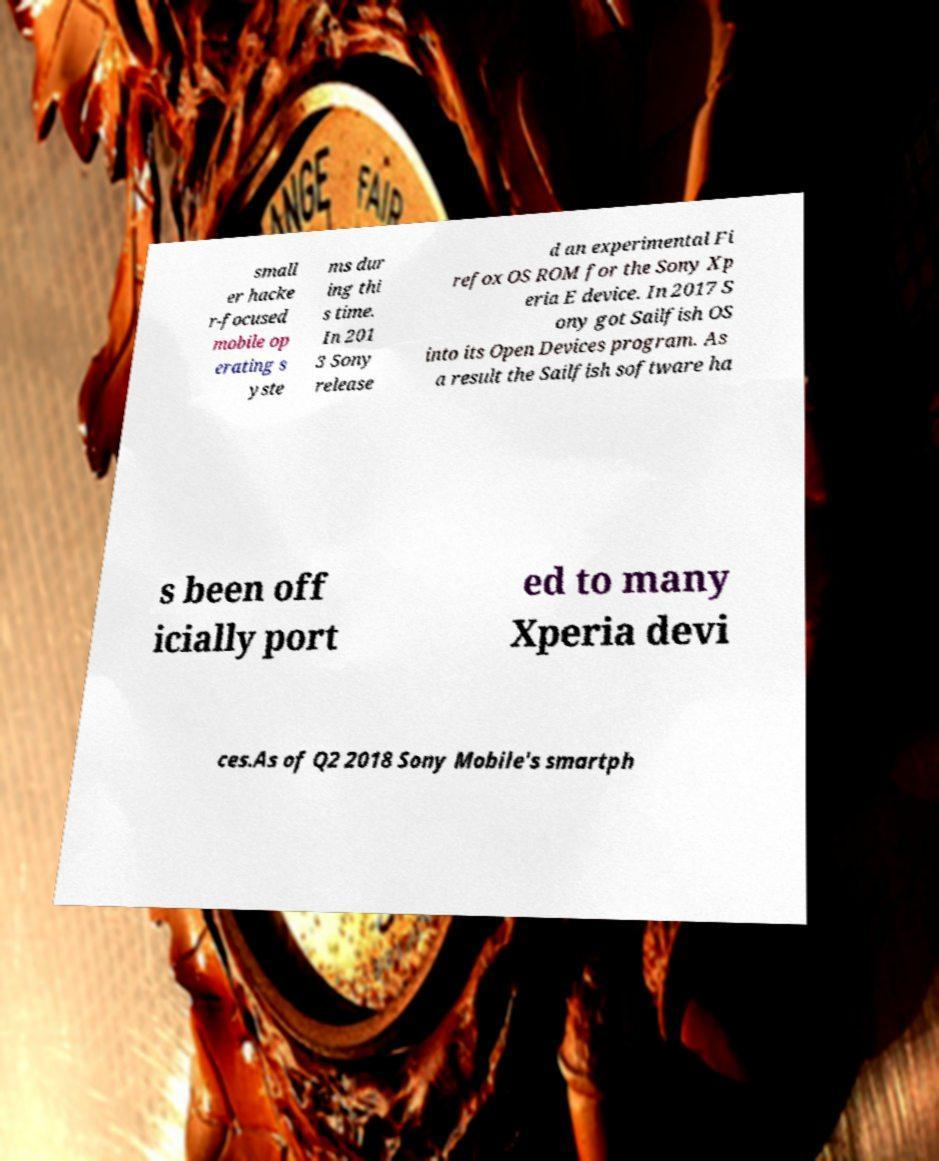Could you extract and type out the text from this image? small er hacke r-focused mobile op erating s yste ms dur ing thi s time. In 201 3 Sony release d an experimental Fi refox OS ROM for the Sony Xp eria E device. In 2017 S ony got Sailfish OS into its Open Devices program. As a result the Sailfish software ha s been off icially port ed to many Xperia devi ces.As of Q2 2018 Sony Mobile's smartph 